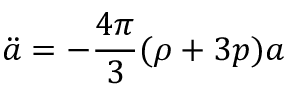<formula> <loc_0><loc_0><loc_500><loc_500>\ddot { a } = - { \frac { 4 \pi } { 3 } } ( \rho + 3 p ) a</formula> 